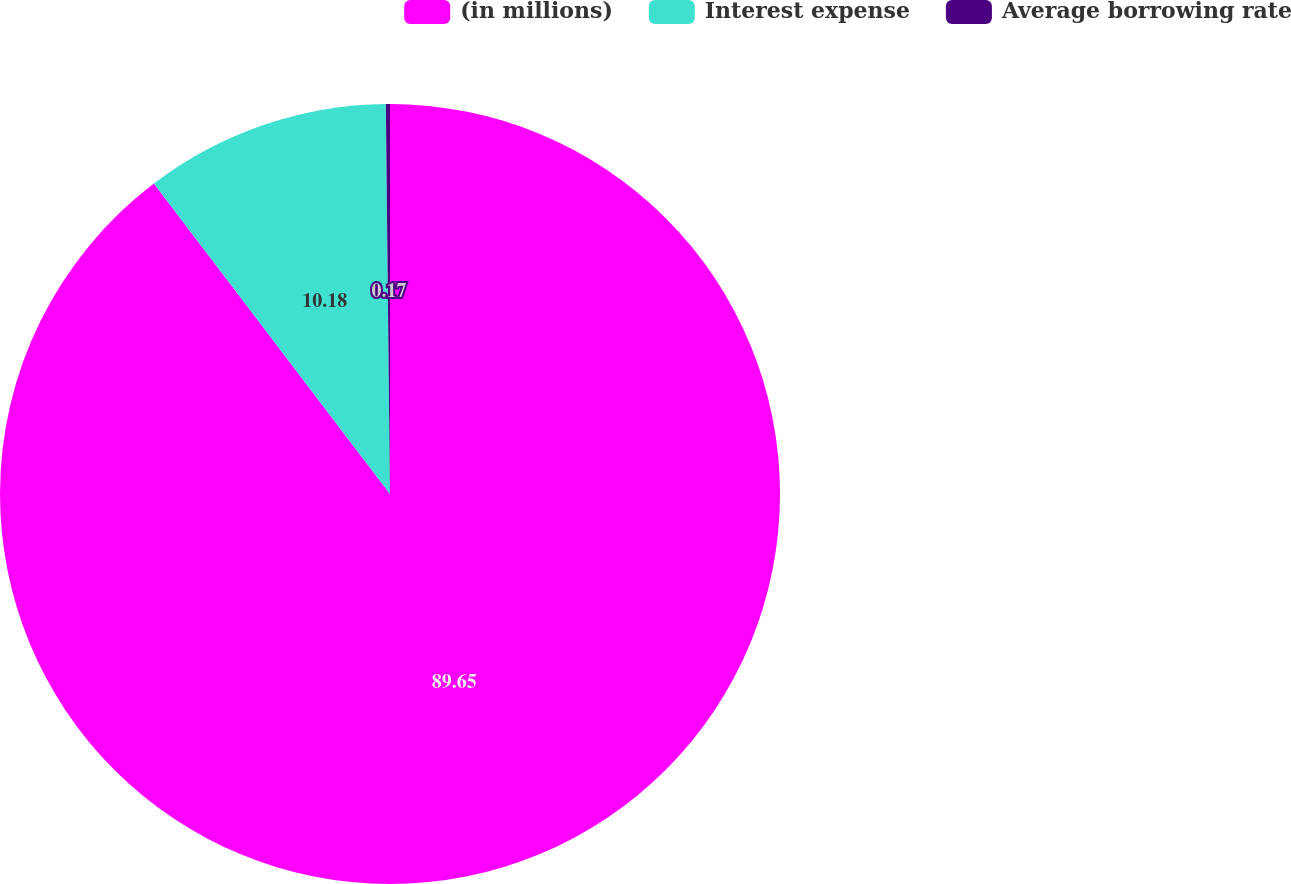<chart> <loc_0><loc_0><loc_500><loc_500><pie_chart><fcel>(in millions)<fcel>Interest expense<fcel>Average borrowing rate<nl><fcel>89.65%<fcel>10.18%<fcel>0.17%<nl></chart> 